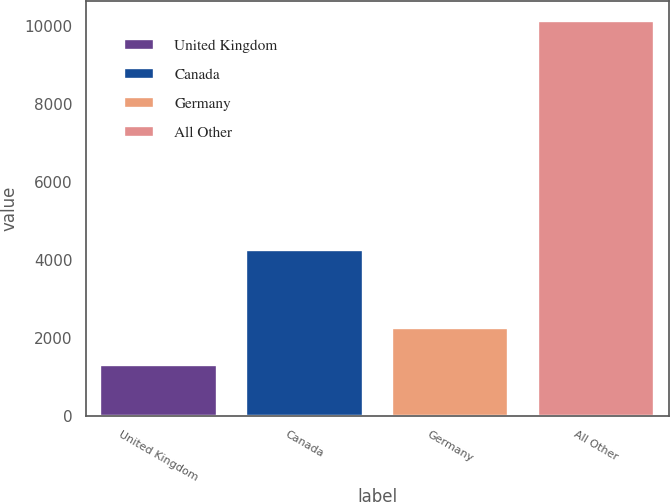Convert chart to OTSL. <chart><loc_0><loc_0><loc_500><loc_500><bar_chart><fcel>United Kingdom<fcel>Canada<fcel>Germany<fcel>All Other<nl><fcel>1302<fcel>4264<fcel>2254<fcel>10135<nl></chart> 